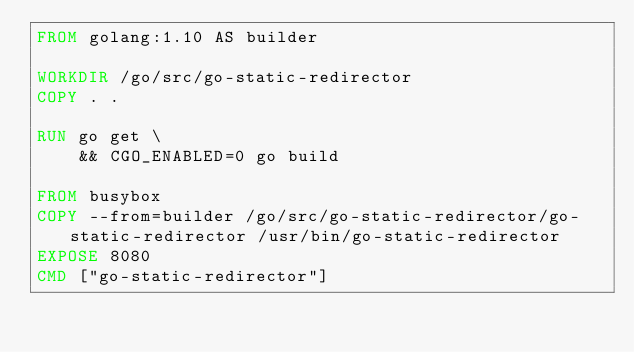Convert code to text. <code><loc_0><loc_0><loc_500><loc_500><_Dockerfile_>FROM golang:1.10 AS builder

WORKDIR /go/src/go-static-redirector
COPY . .

RUN go get \
    && CGO_ENABLED=0 go build

FROM busybox
COPY --from=builder /go/src/go-static-redirector/go-static-redirector /usr/bin/go-static-redirector
EXPOSE 8080
CMD ["go-static-redirector"]
</code> 